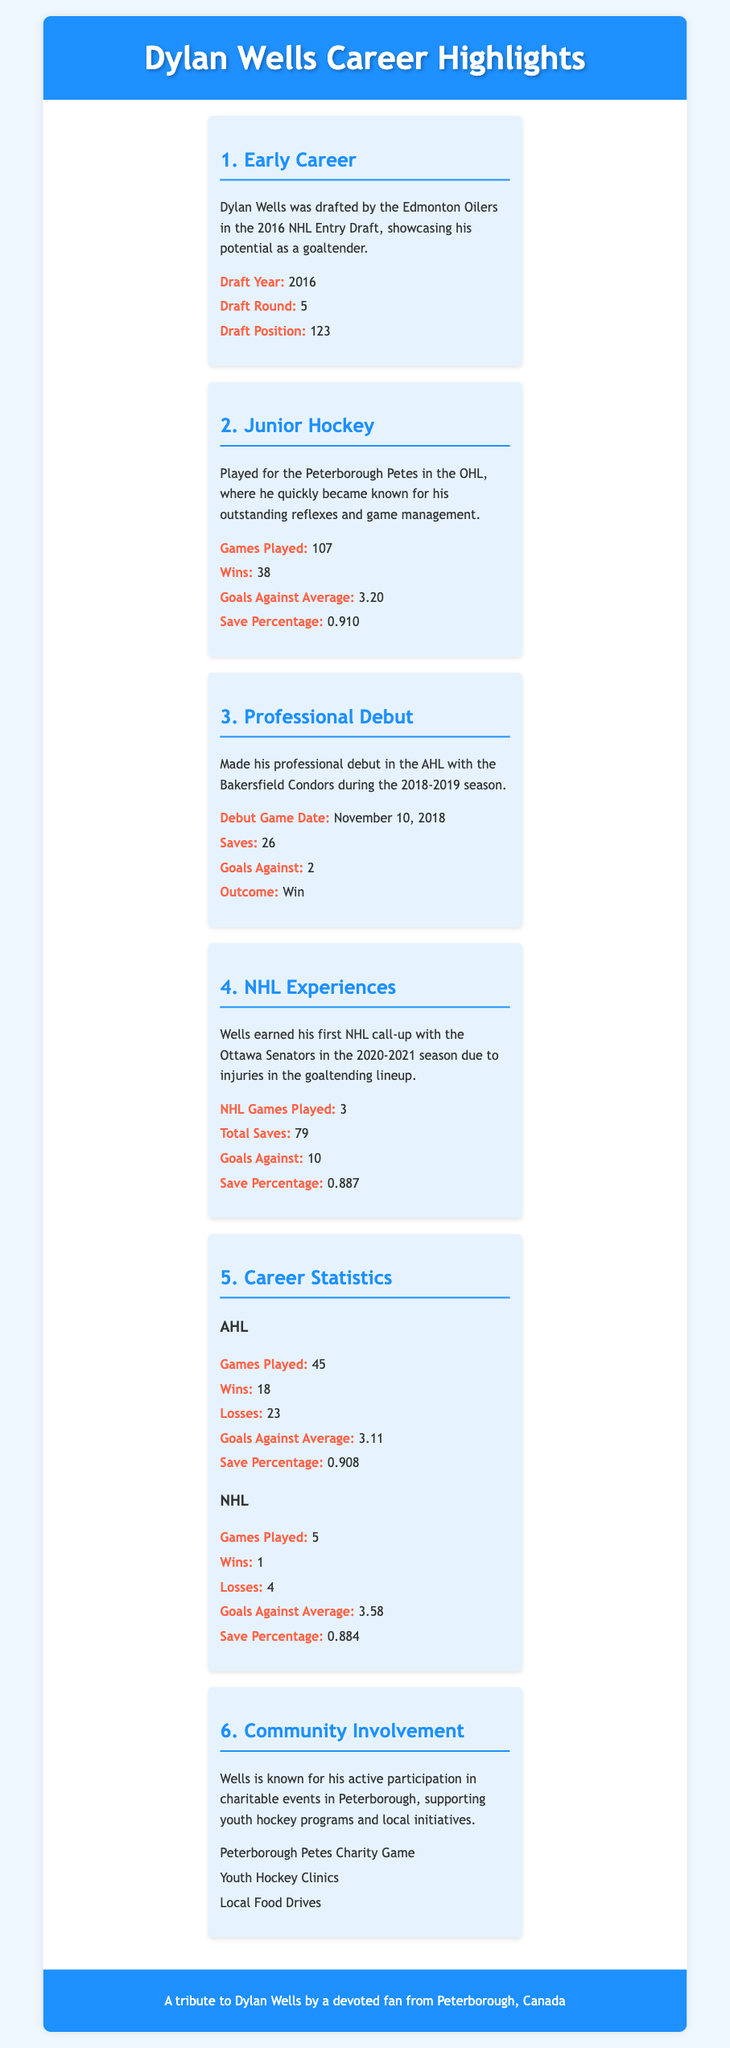What year was Dylan Wells drafted? Dylan Wells was drafted in the year 2016 as noted in the Early Career section.
Answer: 2016 How many wins did Wells achieve during his junior hockey career? In the Junior Hockey section, it states that he had 38 wins during his time with the Peterborough Petes.
Answer: 38 What was Dylan Wells' Goals Against Average in the AHL? The Career Statistics section states his AHL Goals Against Average was 3.11.
Answer: 3.11 Which team did Dylan Wells debut with in the AHL? The Professional Debut section mentions that he made his debut with the Bakersfield Condors in the AHL.
Answer: Bakersfield Condors What is the total number of NHL games Dylan Wells has played? According to the NHL Experiences and Career Statistics sections, he has played a total of 5 NHL games.
Answer: 5 What was the outcome of his debut game in the AHL? The Professional Debut section indicates that the outcome of his debut game was a win.
Answer: Win Which charity event does Dylan Wells participate in? The Community Involvement section lists the Peterborough Petes Charity Game as one of the events he participates in.
Answer: Peterborough Petes Charity Game What was Dylan Wells' save percentage in the NHL? The Career Statistics section shows his NHL save percentage as 0.884.
Answer: 0.884 How many goals against did Wells have in his NHL appearances? The NHL Experiences section indicates he had 10 goals against in his NHL appearances.
Answer: 10 